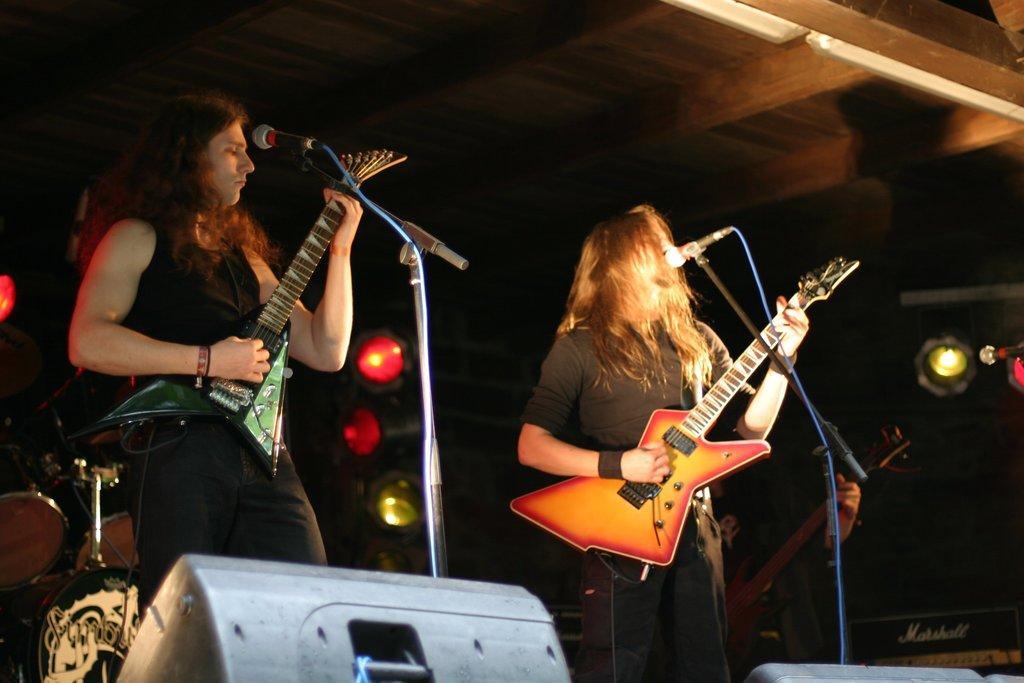Please provide a concise description of this image. In this image we can see few persons are playing guitars, microphones on the stands and at the bottom there are objects. In the background the image is dark but we can see a musical instruments, lights, roof and on the right side there is a mic. 